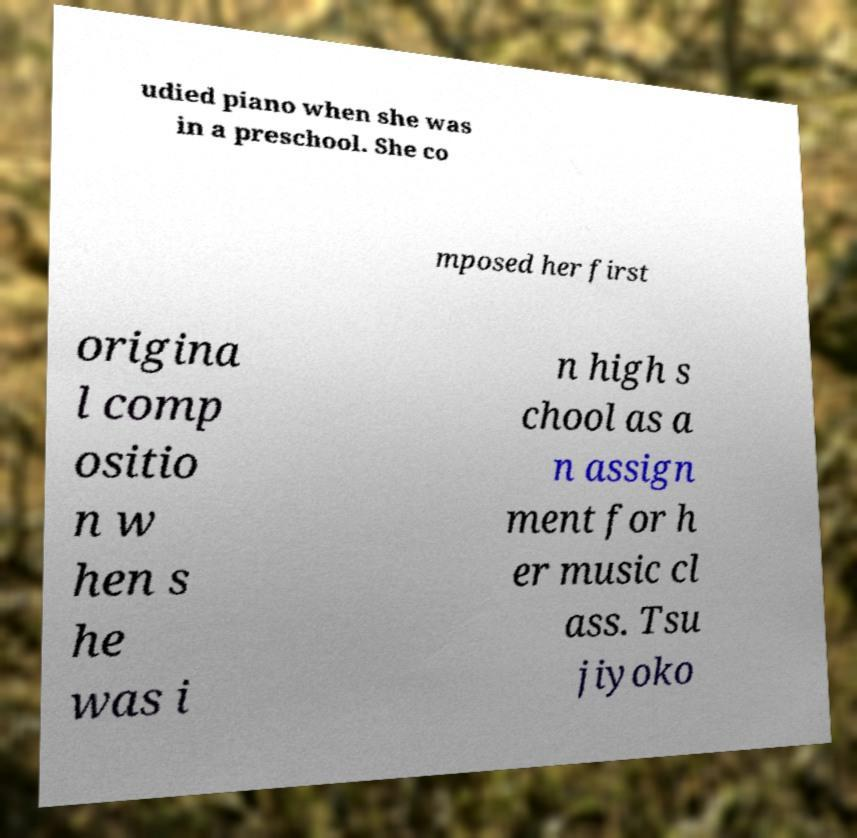There's text embedded in this image that I need extracted. Can you transcribe it verbatim? udied piano when she was in a preschool. She co mposed her first origina l comp ositio n w hen s he was i n high s chool as a n assign ment for h er music cl ass. Tsu jiyoko 